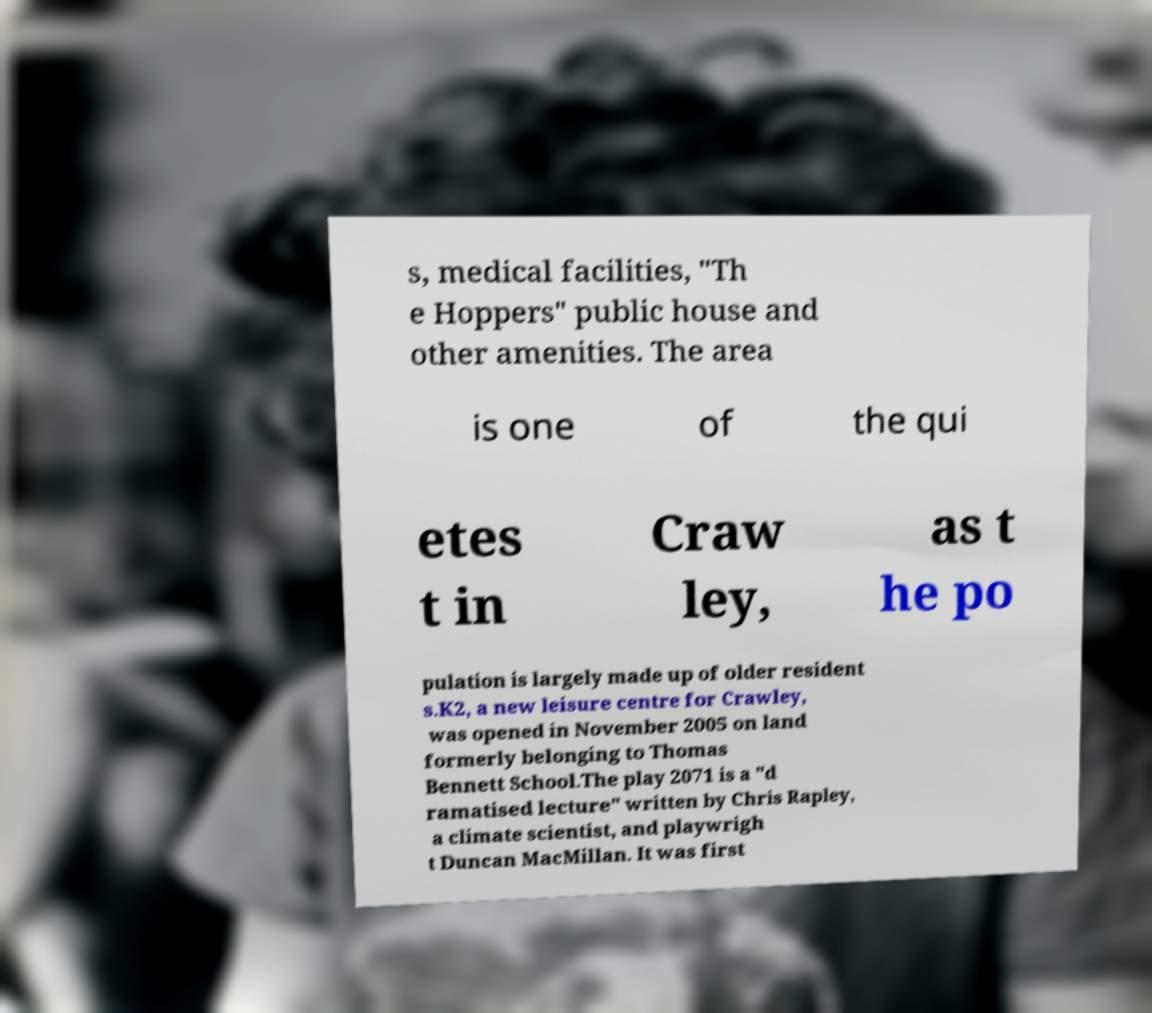Could you extract and type out the text from this image? s, medical facilities, "Th e Hoppers" public house and other amenities. The area is one of the qui etes t in Craw ley, as t he po pulation is largely made up of older resident s.K2, a new leisure centre for Crawley, was opened in November 2005 on land formerly belonging to Thomas Bennett School.The play 2071 is a "d ramatised lecture" written by Chris Rapley, a climate scientist, and playwrigh t Duncan MacMillan. It was first 